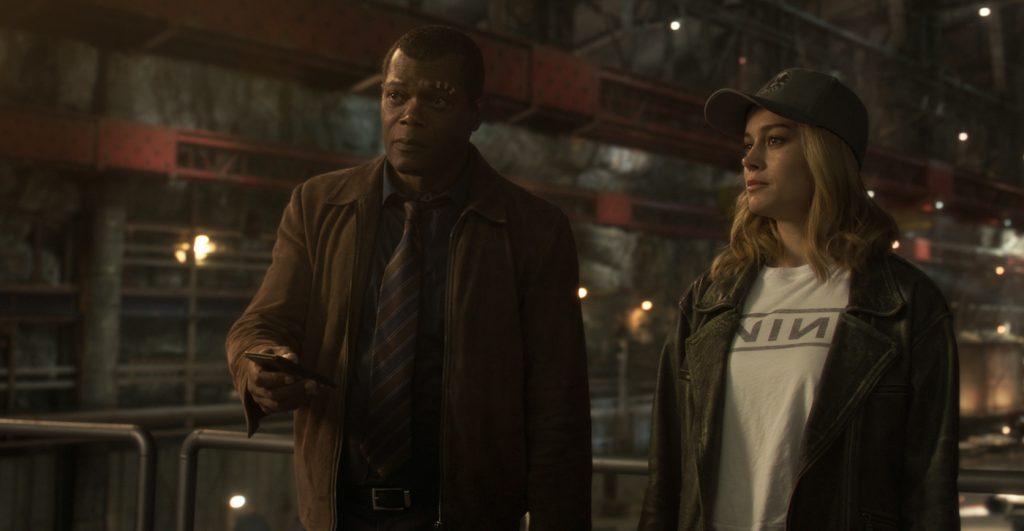Describe the attire of both characters and how it reflects their personality. Nick Fury wears a brown leather jacket, paired with a dress shirt and tie, projecting an air of authority and professionalism consistent with his role as a high-ranking spy. His attire is practical yet commanding, indicative of his no-nonsense personality and leadership qualities. Carol Danvers, on the other hand, sports a casual white 'NIN' t-shirt and a black baseball cap, showcasing her laid-back, rebellious spirit and her rock-n-roll edge. Her outfit, completed with a dark leather jacket, reflects her nonconformist attitude and readiness for action, a blend of casual defiance and combat readiness. How might their attire change if they were in a high-stakes scene in deep space? In a high-stakes scene set in deep space, Nick Fury and Carol Danvers would likely don advanced, high-tech space suits. Fury's suit might be equipped with various tactical gadgets, communication devices, and protective armor, reflecting his strategic mind and preparation for any eventuality. Carol's suit would be sleek yet durable, embodying her strength and agility, with features highlighting her role as a fighter pilot and her ability to navigate and combat threats in extreme environments. Both suits would be designed to withstand the rigors of space, integrating elements such as oxygen supply, advanced sensors, and enhanced mobility. What if they had to attend a high-profile event on Earth—how would they dress? If Nick Fury and Carol Danvers had to attend a high-profile event on Earth, their attire would shift to suit the sophisticated environment. Fury would don an impeccably tailored suit, possibly in dark shades, complete with a tie and polished shoes, exuding his authoritative and polished demeanor. Carol, maintaining her unique edge, might opt for a stylish yet understated dress or a smart pantsuit, accessorized minimally to reflect her unpretentious nature while still appearing elegant and composed. Both would seamlessly blend into the formal setting, showcasing their adaptability and poise. 